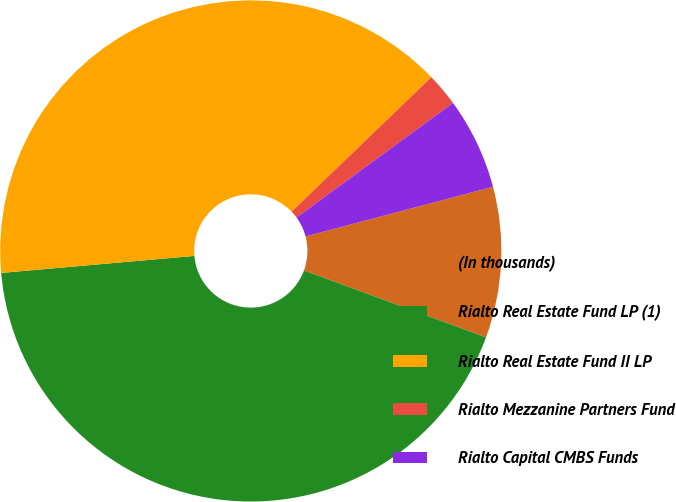<chart> <loc_0><loc_0><loc_500><loc_500><pie_chart><fcel>(In thousands)<fcel>Rialto Real Estate Fund LP (1)<fcel>Rialto Real Estate Fund II LP<fcel>Rialto Mezzanine Partners Fund<fcel>Rialto Capital CMBS Funds<nl><fcel>9.73%<fcel>42.99%<fcel>39.2%<fcel>2.14%<fcel>5.93%<nl></chart> 